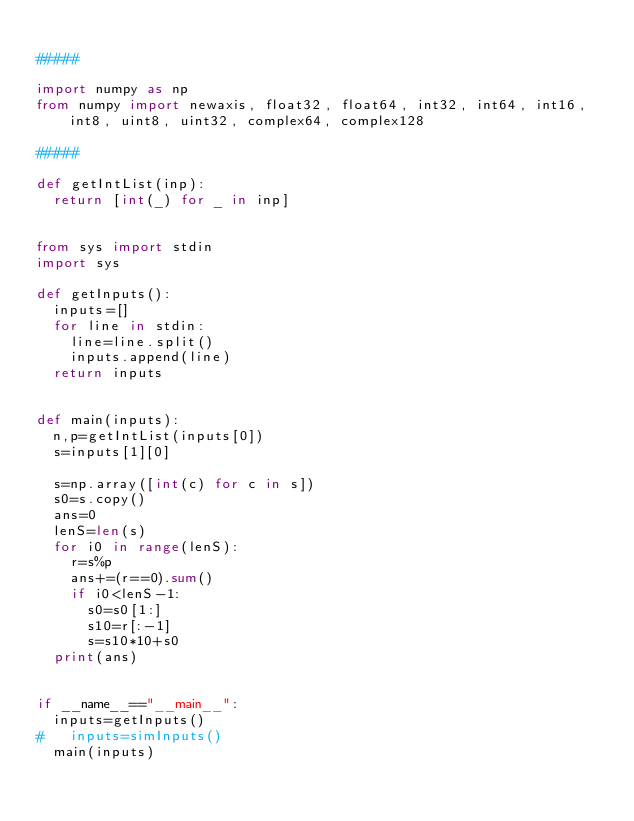<code> <loc_0><loc_0><loc_500><loc_500><_Python_>
#####

import numpy as np
from numpy import newaxis, float32, float64, int32, int64, int16, int8, uint8, uint32, complex64, complex128

#####

def getIntList(inp):
	return [int(_) for _ in inp]


from sys import stdin
import sys

def getInputs():
	inputs=[]
	for line in stdin:
		line=line.split()
		inputs.append(line)
	return inputs

	
def main(inputs):
	n,p=getIntList(inputs[0])
	s=inputs[1][0]
	
	s=np.array([int(c) for c in s])
	s0=s.copy()
	ans=0
	lenS=len(s)
	for i0 in range(lenS):
		r=s%p
		ans+=(r==0).sum()
		if i0<lenS-1:
			s0=s0[1:]
			s10=r[:-1]
			s=s10*10+s0
	print(ans)
	

if __name__=="__main__":
	inputs=getInputs()
# 	inputs=simInputs()
	main(inputs)
	</code> 